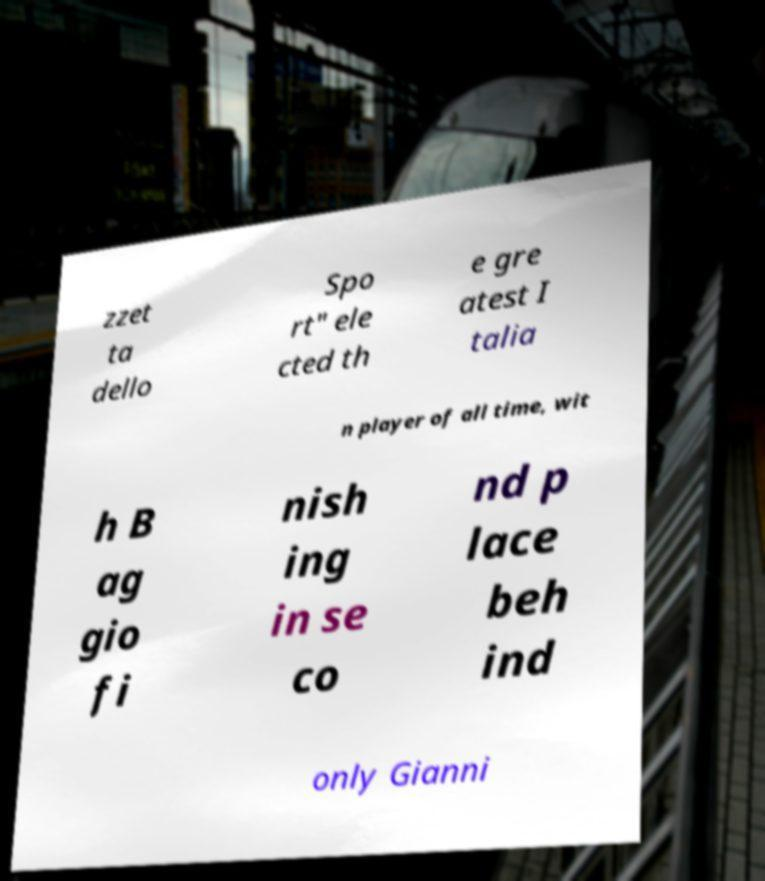Please identify and transcribe the text found in this image. zzet ta dello Spo rt" ele cted th e gre atest I talia n player of all time, wit h B ag gio fi nish ing in se co nd p lace beh ind only Gianni 